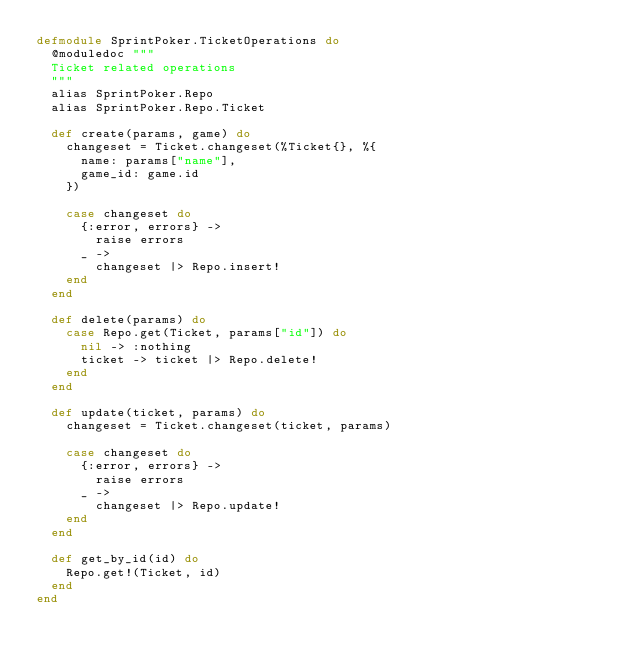<code> <loc_0><loc_0><loc_500><loc_500><_Elixir_>defmodule SprintPoker.TicketOperations do
  @moduledoc """
  Ticket related operations
  """
  alias SprintPoker.Repo
  alias SprintPoker.Repo.Ticket

  def create(params, game) do
    changeset = Ticket.changeset(%Ticket{}, %{
      name: params["name"],
      game_id: game.id
    })

    case changeset do
      {:error, errors} ->
        raise errors
      _ ->
        changeset |> Repo.insert!
    end
  end

  def delete(params) do
    case Repo.get(Ticket, params["id"]) do
      nil -> :nothing
      ticket -> ticket |> Repo.delete!
    end
  end

  def update(ticket, params) do
    changeset = Ticket.changeset(ticket, params)

    case changeset do
      {:error, errors} ->
        raise errors
      _ ->
        changeset |> Repo.update!
    end
  end

  def get_by_id(id) do
    Repo.get!(Ticket, id)
  end
end
</code> 